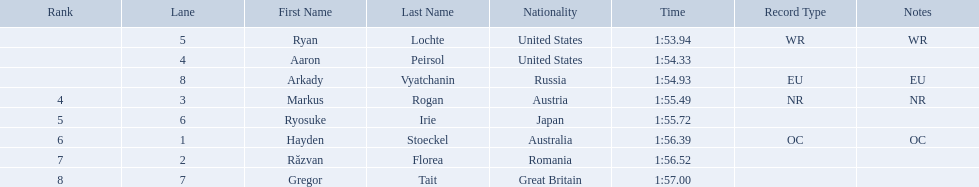Who are the swimmers? Ryan Lochte, Aaron Peirsol, Arkady Vyatchanin, Markus Rogan, Ryosuke Irie, Hayden Stoeckel, Răzvan Florea, Gregor Tait. What is ryosuke irie's time? 1:55.72. 